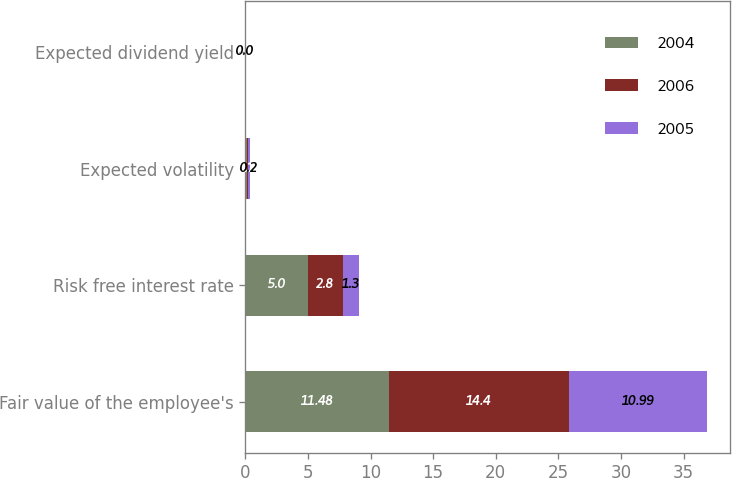Convert chart. <chart><loc_0><loc_0><loc_500><loc_500><stacked_bar_chart><ecel><fcel>Fair value of the employee's<fcel>Risk free interest rate<fcel>Expected volatility<fcel>Expected dividend yield<nl><fcel>2004<fcel>11.48<fcel>5<fcel>0.1<fcel>0<nl><fcel>2006<fcel>14.4<fcel>2.8<fcel>0.1<fcel>0<nl><fcel>2005<fcel>10.99<fcel>1.3<fcel>0.2<fcel>0<nl></chart> 